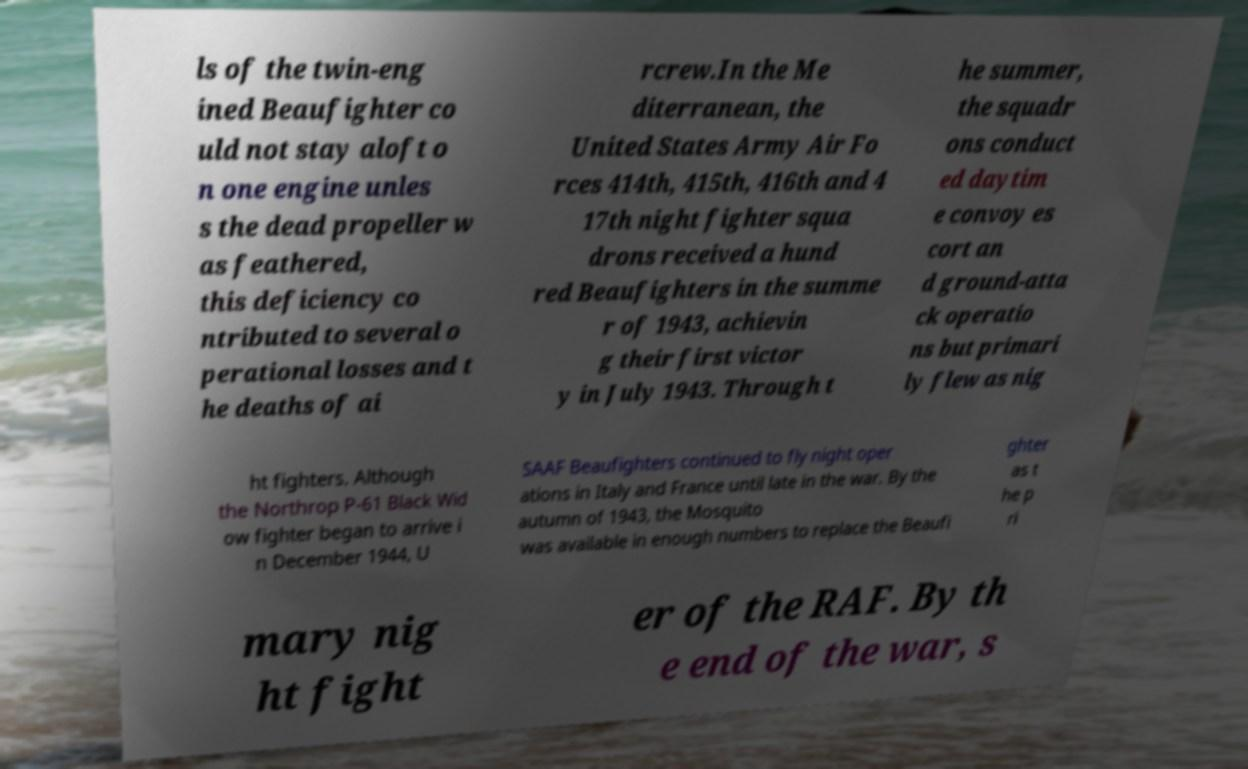Can you accurately transcribe the text from the provided image for me? ls of the twin-eng ined Beaufighter co uld not stay aloft o n one engine unles s the dead propeller w as feathered, this deficiency co ntributed to several o perational losses and t he deaths of ai rcrew.In the Me diterranean, the United States Army Air Fo rces 414th, 415th, 416th and 4 17th night fighter squa drons received a hund red Beaufighters in the summe r of 1943, achievin g their first victor y in July 1943. Through t he summer, the squadr ons conduct ed daytim e convoy es cort an d ground-atta ck operatio ns but primari ly flew as nig ht fighters. Although the Northrop P-61 Black Wid ow fighter began to arrive i n December 1944, U SAAF Beaufighters continued to fly night oper ations in Italy and France until late in the war. By the autumn of 1943, the Mosquito was available in enough numbers to replace the Beaufi ghter as t he p ri mary nig ht fight er of the RAF. By th e end of the war, s 